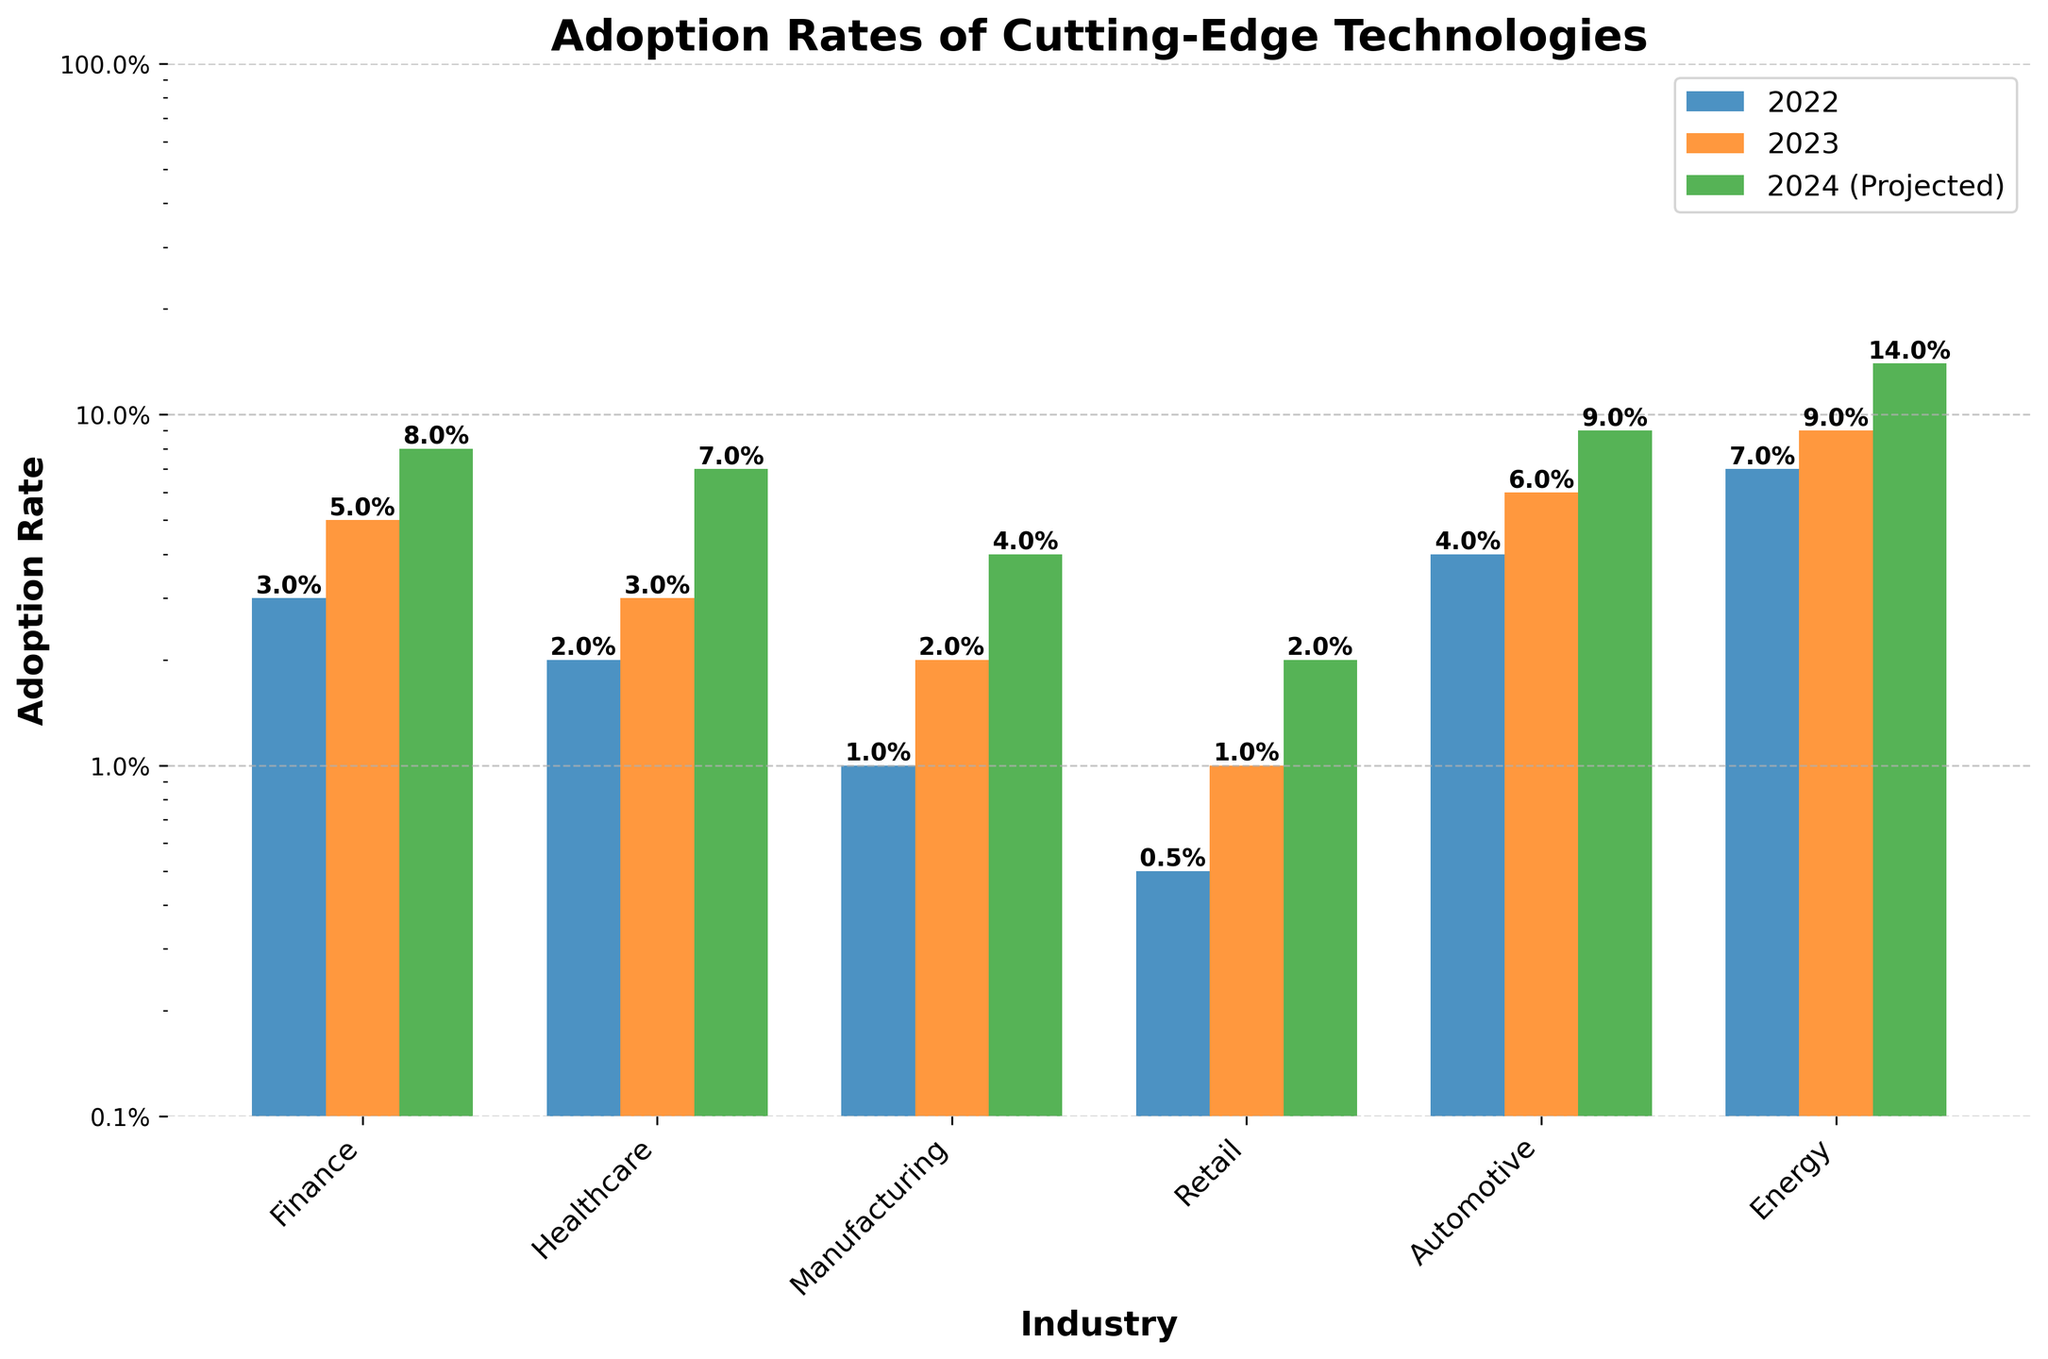what is the title of the plot? The title of the plot is shown at the top and it reads 'Adoption Rates of Cutting-Edge Technologies'.
Answer: Adoption Rates of Cutting-Edge Technologies what axis uses a logarithmic scale? The y-axis, which measures the adoption rate, uses a logarithmic scale as indicated by the evenly spaced tick marks that represent powers of ten.
Answer: y-axis which industry has the highest projected growth rate in 2024? By observing the bar heights for the projected growth rate in 2024, the Energy industry, which uses solar panels, has the highest projected growth rate.
Answer: Energy how do the adoption rates of blockchain in the finance industry compare from 2022 to 2023? The adoption rate for blockchain in the finance industry increased from 3% in 2022 to 5% in 2023, as shown by the height of the bars.
Answer: Increased from 3% to 5% what is the adoption rate of augmented reality in the retail industry in 2023? The adoption rate of augmented reality in the retail industry in 2023 is represented by the height of the orange bar, which is 1%.
Answer: 1% which technology has shown the highest overall growth from 2022 to the projected growth rate in 2024? By comparing the height of the bars from 2022 to the projected growth rate in 2024, the automotive industry with electric vehicles shows an increase from 4% in 2022 to 9% in 2024, indicating the highest overall growth.
Answer: Electric Vehicles are there any industries in which the adoption rate in 2023 is double that of 2022? The adoption rates for IoT in manufacturing, augmented reality in retail, and electric vehicles in automotive doubled from 2022 to 2023: from 1% to 2%, from 0.5% to 1%, and from 4% to 6% respectively.
Answer: Manufacturing, Retail, Automotive compare the adoption rates of blockchain in finance and AI in healthcare in 2023. which one is higher? In 2023, the orange bar for blockchain in finance is at 5%, whereas the bar for AI in healthcare is at 3%. Thus, blockchain in finance has a higher adoption rate.
Answer: Blockchain in finance what is the adoption rate for internet of things (IoT) in manufacturing projected to be in 2024? The projected growth rate for the Internet of Things (IoT) in manufacturing for 2024 is represented by the height of the green bar, showing a value of 4%.
Answer: 4% which technology in which industry had the least adoption rate in 2022? The technology with the least adoption rate in 2022 shown by the shortest blue bar is augmented reality in the retail industry, with a rate of 0.5%.
Answer: Augmented reality in retail 